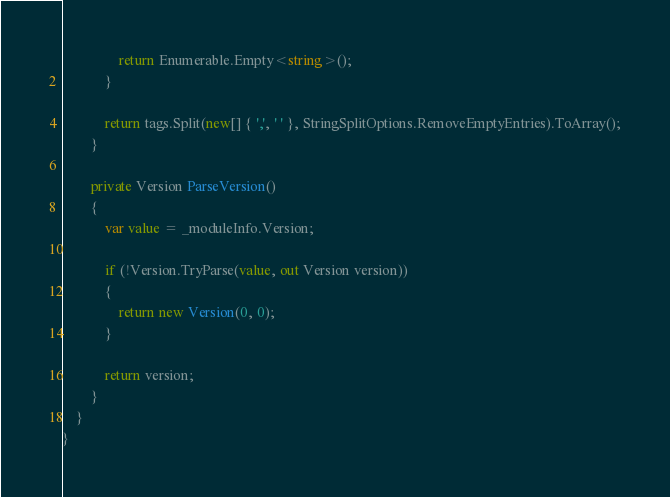Convert code to text. <code><loc_0><loc_0><loc_500><loc_500><_C#_>                return Enumerable.Empty<string>();
            }

            return tags.Split(new[] { ',', ' ' }, StringSplitOptions.RemoveEmptyEntries).ToArray();
        }

        private Version ParseVersion()
        {
            var value = _moduleInfo.Version;

            if (!Version.TryParse(value, out Version version))
            {
                return new Version(0, 0);
            }

            return version;
        }
    }
}</code> 